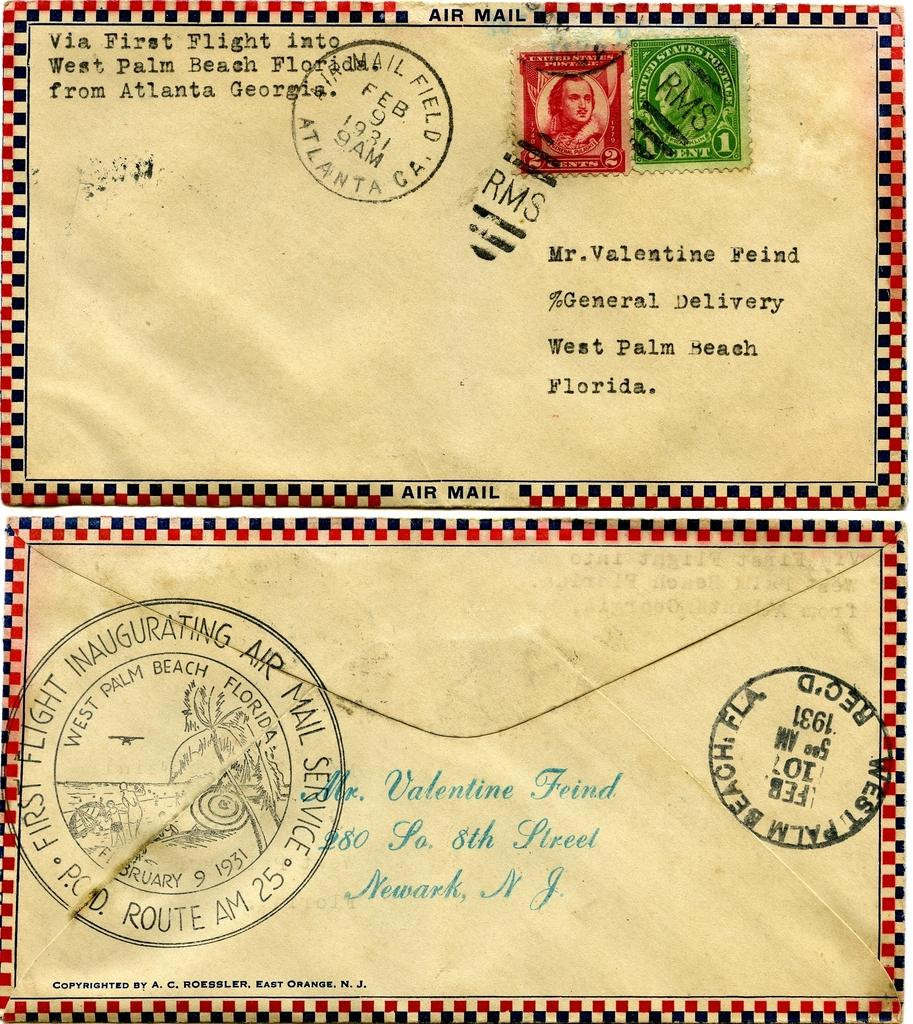<image>
Write a terse but informative summary of the picture. Two envelopes is addressed to Mr. Valentine Fried with one envelope stamped West Palm Beach Florida on the back and two stamps on the front. 